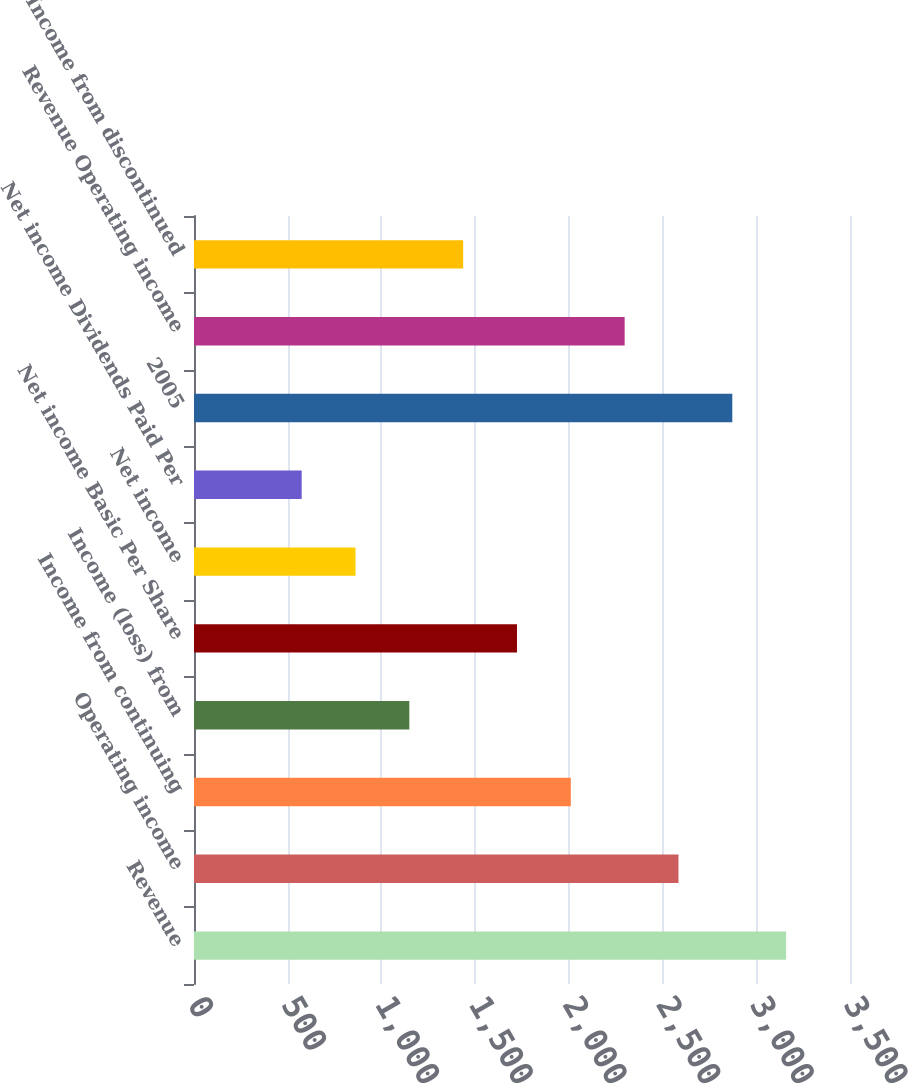<chart> <loc_0><loc_0><loc_500><loc_500><bar_chart><fcel>Revenue<fcel>Operating income<fcel>Income from continuing<fcel>Income (loss) from<fcel>Net income Basic Per Share<fcel>Net income<fcel>Net income Dividends Paid Per<fcel>2005<fcel>Revenue Operating income<fcel>Income from discontinued<nl><fcel>3159.2<fcel>2584.82<fcel>2010.44<fcel>1148.87<fcel>1723.25<fcel>861.68<fcel>574.49<fcel>2872.01<fcel>2297.63<fcel>1436.06<nl></chart> 